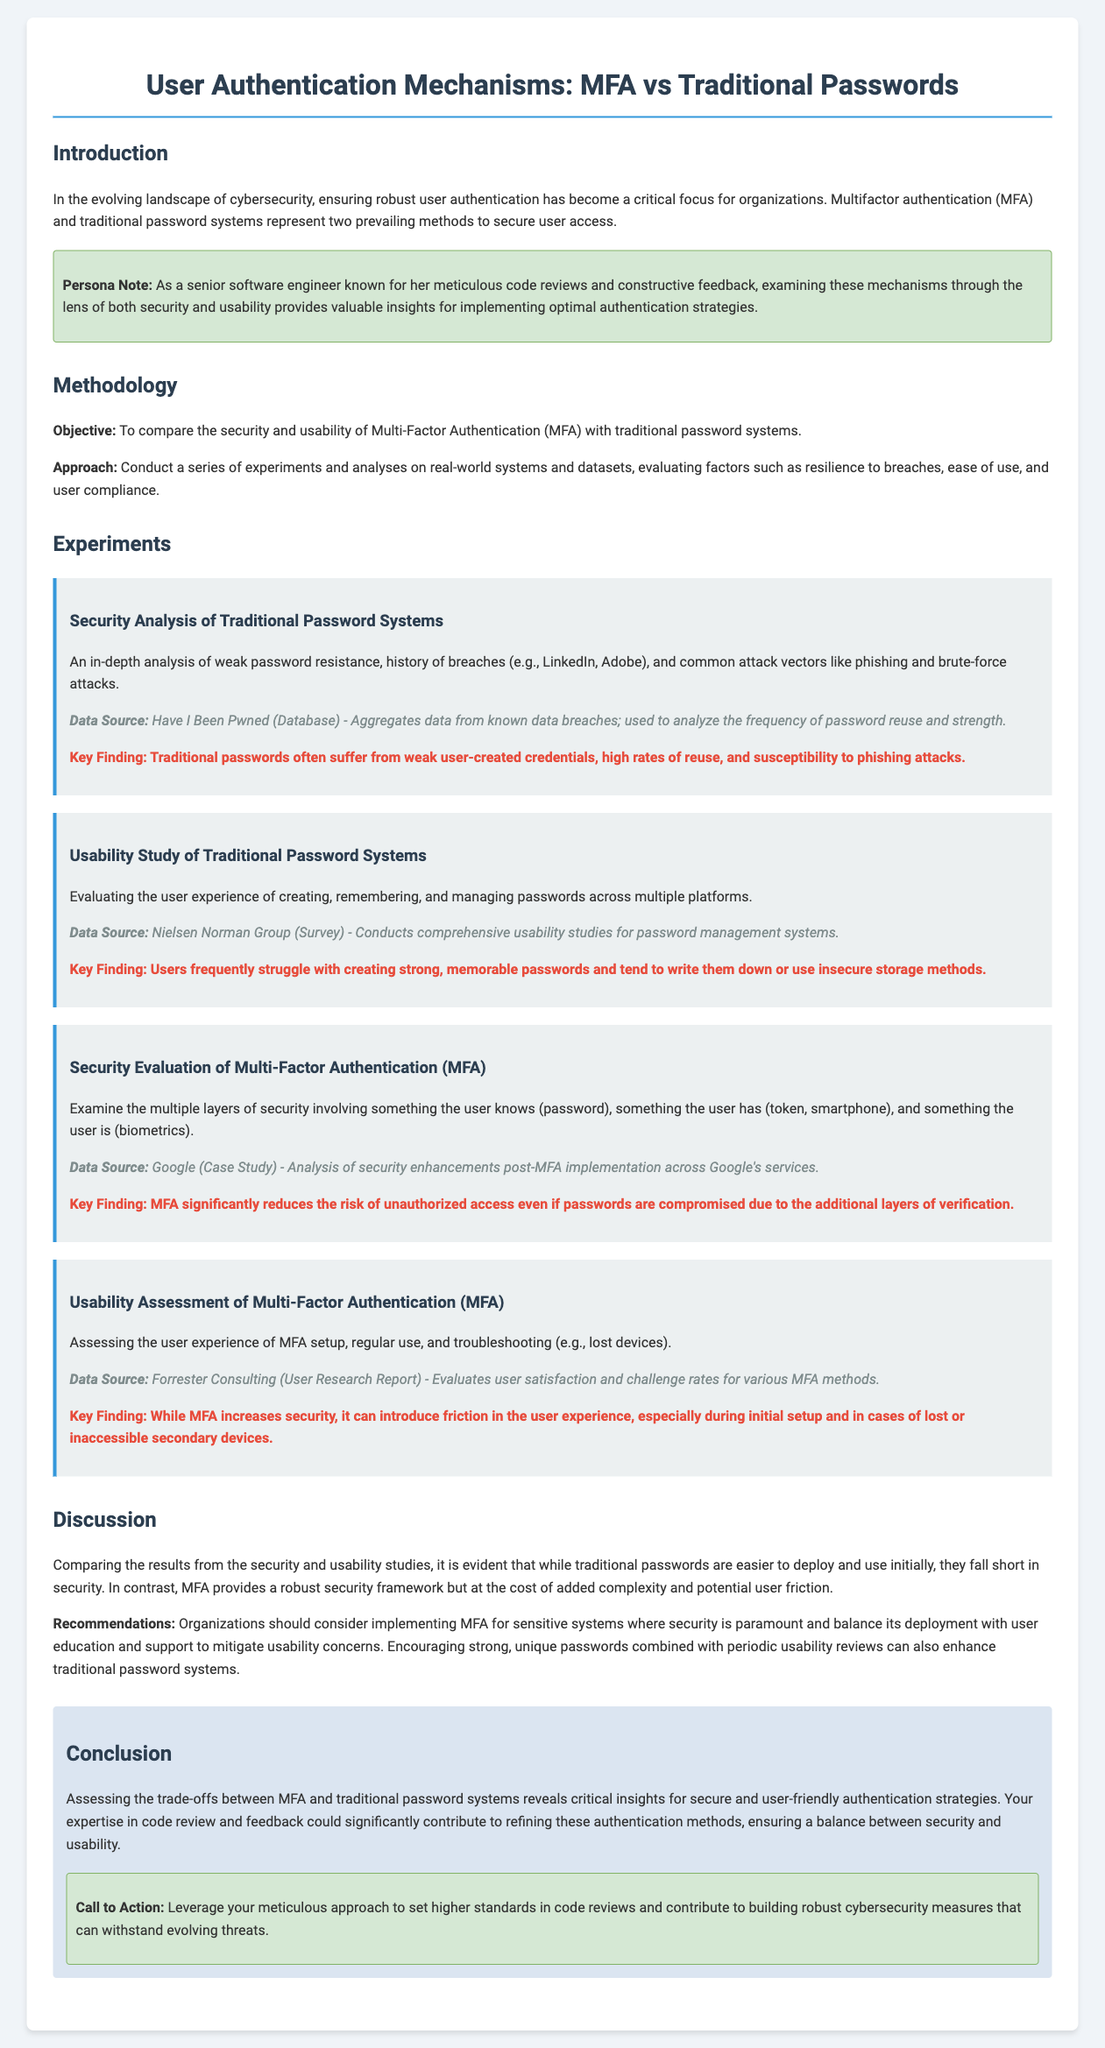what is the main focus of the lab report? The main focus of the lab report is to compare the security and usability of Multi-Factor Authentication (MFA) with traditional password systems.
Answer: comparison of security and usability which organization is mentioned as a data source for usability studies of password management? The Nielsen Norman Group is mentioned as a data source for usability studies of password management systems.
Answer: Nielsen Norman Group what was identified as a key finding related to traditional password systems? Traditional passwords often suffer from weak user-created credentials, high rates of reuse, and susceptibility to phishing attacks.
Answer: weak user-created credentials, high rates of reuse, susceptibility to phishing what is one recommendation provided in the discussion section? Organizations should consider implementing MFA for sensitive systems where security is paramount.
Answer: implement MFA for sensitive systems how does MFA impact user experience according to the report? While MFA increases security, it can introduce friction in the user experience, especially during initial setup and in cases of lost or inaccessible secondary devices.
Answer: introduce friction in user experience what type of authentication involves something the user knows, has, and is? Multi-Factor Authentication (MFA) involves something the user knows (password), something the user has (token, smartphone), and something the user is (biometrics).
Answer: Multi-Factor Authentication (MFA) which section contains the key findings of each experiment? The experiments section contains the key findings of each experiment.
Answer: experiments section what is the color of the background in the conclusion section? The background color in the conclusion section is light blue.
Answer: light blue 